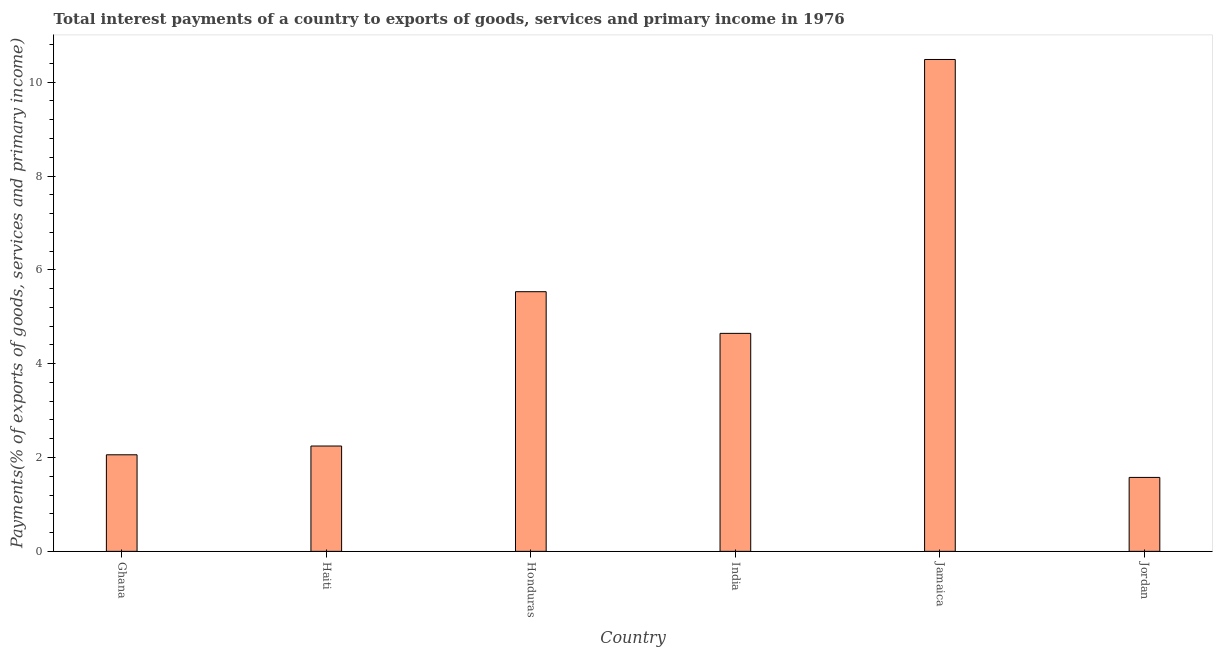Does the graph contain any zero values?
Provide a short and direct response. No. What is the title of the graph?
Your answer should be compact. Total interest payments of a country to exports of goods, services and primary income in 1976. What is the label or title of the X-axis?
Make the answer very short. Country. What is the label or title of the Y-axis?
Provide a short and direct response. Payments(% of exports of goods, services and primary income). What is the total interest payments on external debt in Haiti?
Your answer should be compact. 2.24. Across all countries, what is the maximum total interest payments on external debt?
Make the answer very short. 10.48. Across all countries, what is the minimum total interest payments on external debt?
Your answer should be very brief. 1.58. In which country was the total interest payments on external debt maximum?
Keep it short and to the point. Jamaica. In which country was the total interest payments on external debt minimum?
Offer a very short reply. Jordan. What is the sum of the total interest payments on external debt?
Make the answer very short. 26.54. What is the difference between the total interest payments on external debt in Honduras and Jordan?
Ensure brevity in your answer.  3.96. What is the average total interest payments on external debt per country?
Provide a short and direct response. 4.42. What is the median total interest payments on external debt?
Your answer should be compact. 3.45. In how many countries, is the total interest payments on external debt greater than 10 %?
Ensure brevity in your answer.  1. What is the ratio of the total interest payments on external debt in Ghana to that in Jamaica?
Keep it short and to the point. 0.2. What is the difference between the highest and the second highest total interest payments on external debt?
Your answer should be compact. 4.95. What is the difference between the highest and the lowest total interest payments on external debt?
Give a very brief answer. 8.91. In how many countries, is the total interest payments on external debt greater than the average total interest payments on external debt taken over all countries?
Your answer should be very brief. 3. How many bars are there?
Offer a very short reply. 6. Are all the bars in the graph horizontal?
Ensure brevity in your answer.  No. What is the difference between two consecutive major ticks on the Y-axis?
Offer a very short reply. 2. Are the values on the major ticks of Y-axis written in scientific E-notation?
Ensure brevity in your answer.  No. What is the Payments(% of exports of goods, services and primary income) in Ghana?
Ensure brevity in your answer.  2.06. What is the Payments(% of exports of goods, services and primary income) in Haiti?
Make the answer very short. 2.24. What is the Payments(% of exports of goods, services and primary income) of Honduras?
Your response must be concise. 5.53. What is the Payments(% of exports of goods, services and primary income) in India?
Offer a very short reply. 4.65. What is the Payments(% of exports of goods, services and primary income) of Jamaica?
Your answer should be compact. 10.48. What is the Payments(% of exports of goods, services and primary income) of Jordan?
Your answer should be compact. 1.58. What is the difference between the Payments(% of exports of goods, services and primary income) in Ghana and Haiti?
Give a very brief answer. -0.19. What is the difference between the Payments(% of exports of goods, services and primary income) in Ghana and Honduras?
Offer a very short reply. -3.48. What is the difference between the Payments(% of exports of goods, services and primary income) in Ghana and India?
Your answer should be compact. -2.59. What is the difference between the Payments(% of exports of goods, services and primary income) in Ghana and Jamaica?
Ensure brevity in your answer.  -8.43. What is the difference between the Payments(% of exports of goods, services and primary income) in Ghana and Jordan?
Your answer should be very brief. 0.48. What is the difference between the Payments(% of exports of goods, services and primary income) in Haiti and Honduras?
Keep it short and to the point. -3.29. What is the difference between the Payments(% of exports of goods, services and primary income) in Haiti and India?
Your answer should be very brief. -2.4. What is the difference between the Payments(% of exports of goods, services and primary income) in Haiti and Jamaica?
Provide a short and direct response. -8.24. What is the difference between the Payments(% of exports of goods, services and primary income) in Haiti and Jordan?
Give a very brief answer. 0.67. What is the difference between the Payments(% of exports of goods, services and primary income) in Honduras and India?
Your answer should be compact. 0.89. What is the difference between the Payments(% of exports of goods, services and primary income) in Honduras and Jamaica?
Offer a terse response. -4.95. What is the difference between the Payments(% of exports of goods, services and primary income) in Honduras and Jordan?
Your answer should be very brief. 3.96. What is the difference between the Payments(% of exports of goods, services and primary income) in India and Jamaica?
Your answer should be very brief. -5.84. What is the difference between the Payments(% of exports of goods, services and primary income) in India and Jordan?
Offer a terse response. 3.07. What is the difference between the Payments(% of exports of goods, services and primary income) in Jamaica and Jordan?
Provide a succinct answer. 8.91. What is the ratio of the Payments(% of exports of goods, services and primary income) in Ghana to that in Haiti?
Your answer should be compact. 0.92. What is the ratio of the Payments(% of exports of goods, services and primary income) in Ghana to that in Honduras?
Keep it short and to the point. 0.37. What is the ratio of the Payments(% of exports of goods, services and primary income) in Ghana to that in India?
Provide a short and direct response. 0.44. What is the ratio of the Payments(% of exports of goods, services and primary income) in Ghana to that in Jamaica?
Your answer should be very brief. 0.2. What is the ratio of the Payments(% of exports of goods, services and primary income) in Ghana to that in Jordan?
Provide a succinct answer. 1.31. What is the ratio of the Payments(% of exports of goods, services and primary income) in Haiti to that in Honduras?
Ensure brevity in your answer.  0.41. What is the ratio of the Payments(% of exports of goods, services and primary income) in Haiti to that in India?
Provide a succinct answer. 0.48. What is the ratio of the Payments(% of exports of goods, services and primary income) in Haiti to that in Jamaica?
Offer a terse response. 0.21. What is the ratio of the Payments(% of exports of goods, services and primary income) in Haiti to that in Jordan?
Offer a terse response. 1.43. What is the ratio of the Payments(% of exports of goods, services and primary income) in Honduras to that in India?
Provide a short and direct response. 1.19. What is the ratio of the Payments(% of exports of goods, services and primary income) in Honduras to that in Jamaica?
Offer a terse response. 0.53. What is the ratio of the Payments(% of exports of goods, services and primary income) in Honduras to that in Jordan?
Offer a terse response. 3.51. What is the ratio of the Payments(% of exports of goods, services and primary income) in India to that in Jamaica?
Provide a succinct answer. 0.44. What is the ratio of the Payments(% of exports of goods, services and primary income) in India to that in Jordan?
Make the answer very short. 2.95. What is the ratio of the Payments(% of exports of goods, services and primary income) in Jamaica to that in Jordan?
Provide a succinct answer. 6.65. 